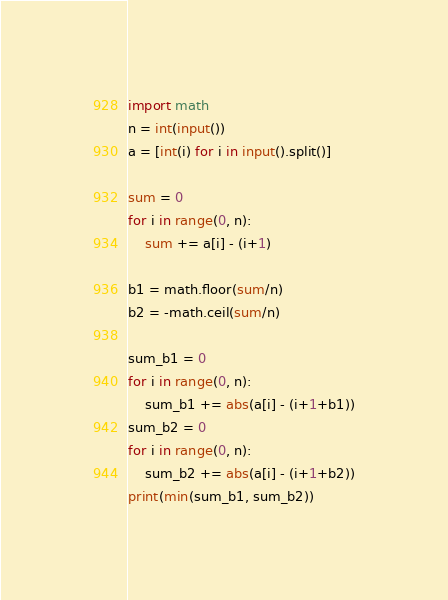Convert code to text. <code><loc_0><loc_0><loc_500><loc_500><_Python_>import math
n = int(input())
a = [int(i) for i in input().split()]

sum = 0
for i in range(0, n):
    sum += a[i] - (i+1)

b1 = math.floor(sum/n)
b2 = -math.ceil(sum/n)

sum_b1 = 0
for i in range(0, n):
    sum_b1 += abs(a[i] - (i+1+b1))
sum_b2 = 0
for i in range(0, n):
    sum_b2 += abs(a[i] - (i+1+b2))
print(min(sum_b1, sum_b2))
</code> 